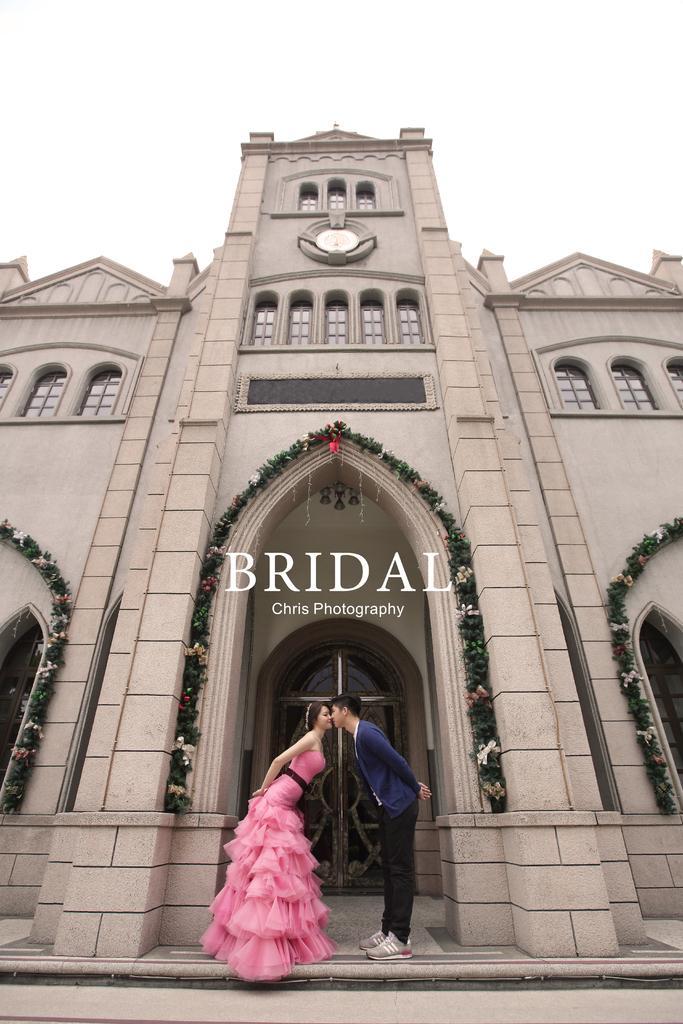How would you summarize this image in a sentence or two? In this picture there are two people standing and kissing each other and we can see building and decorative items. In the middle of the image we can see text. In the background of the image we can see the sky. 